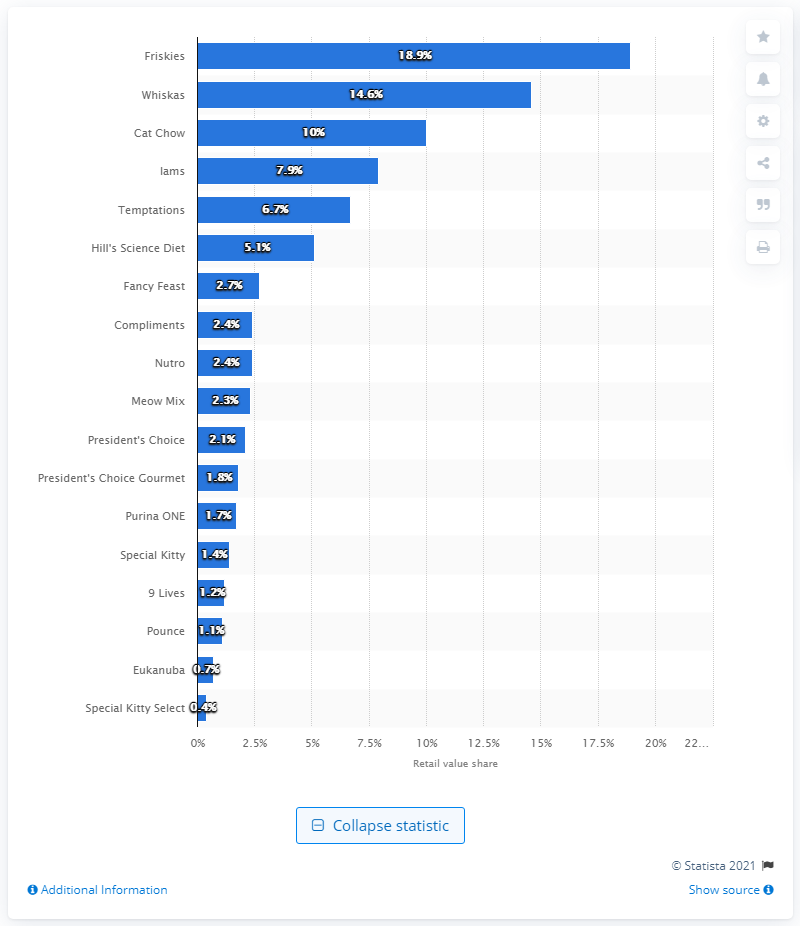List a handful of essential elements in this visual. In Canada in the year 2010, the leading cat food brand was Friskies, according to industry reports. 